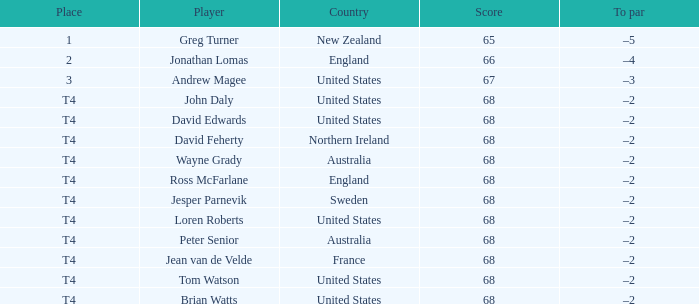Name the Place of england with a Score larger than 66? T4. 